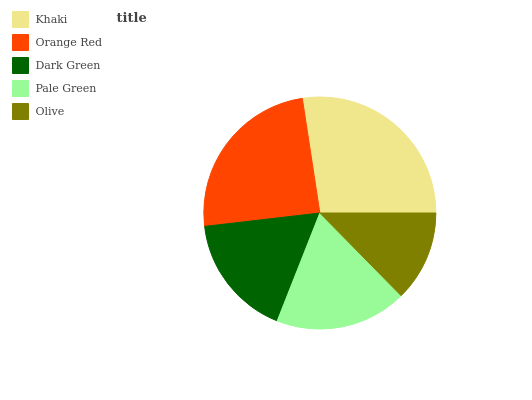Is Olive the minimum?
Answer yes or no. Yes. Is Khaki the maximum?
Answer yes or no. Yes. Is Orange Red the minimum?
Answer yes or no. No. Is Orange Red the maximum?
Answer yes or no. No. Is Khaki greater than Orange Red?
Answer yes or no. Yes. Is Orange Red less than Khaki?
Answer yes or no. Yes. Is Orange Red greater than Khaki?
Answer yes or no. No. Is Khaki less than Orange Red?
Answer yes or no. No. Is Pale Green the high median?
Answer yes or no. Yes. Is Pale Green the low median?
Answer yes or no. Yes. Is Khaki the high median?
Answer yes or no. No. Is Dark Green the low median?
Answer yes or no. No. 